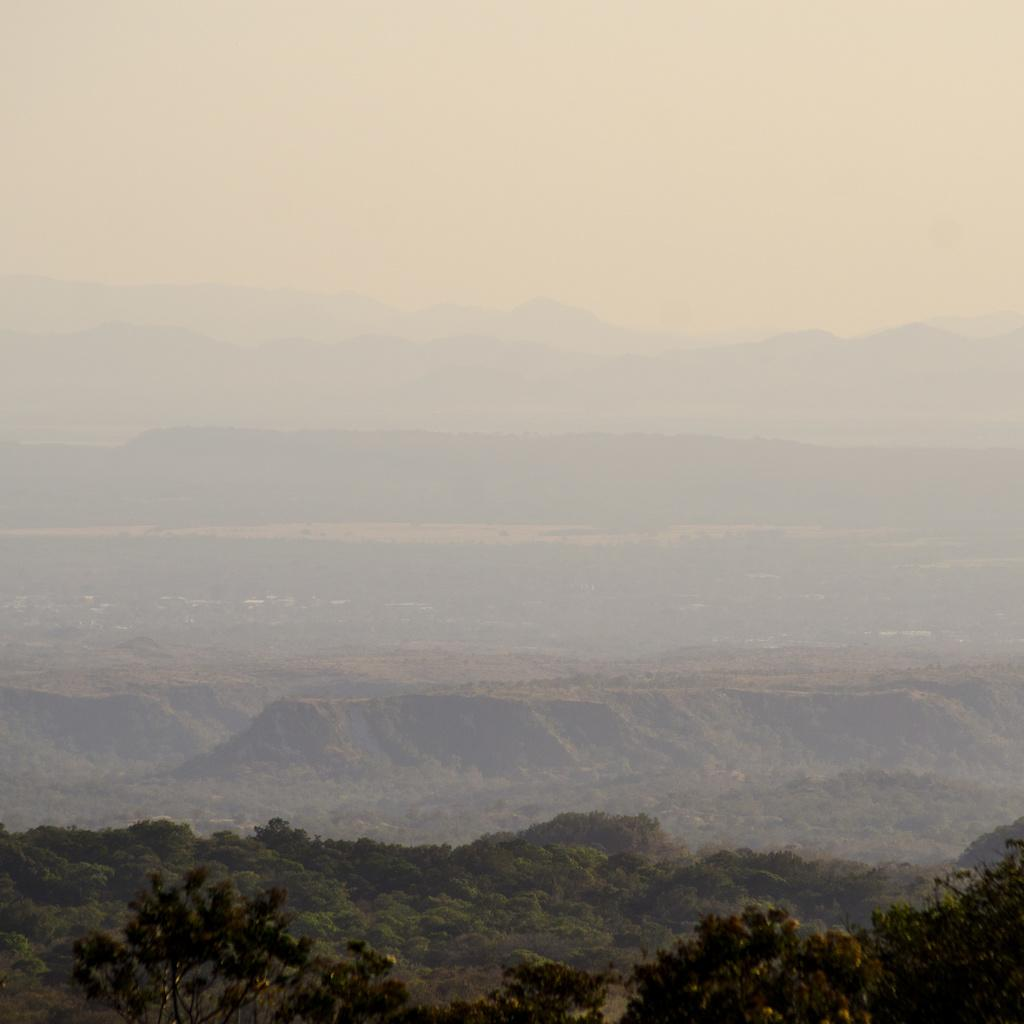What type of vegetation is at the bottom of the image? There are trees at the bottom of the image. What geographical features can be seen in the background of the image? Hills are visible in the background of the image. What part of the natural environment is visible in the background of the image? The sky is visible in the background of the image. Can you see any animals offering their tails to the trees in the image? There are no animals or tails present in the image; it features trees and hills in the background. 